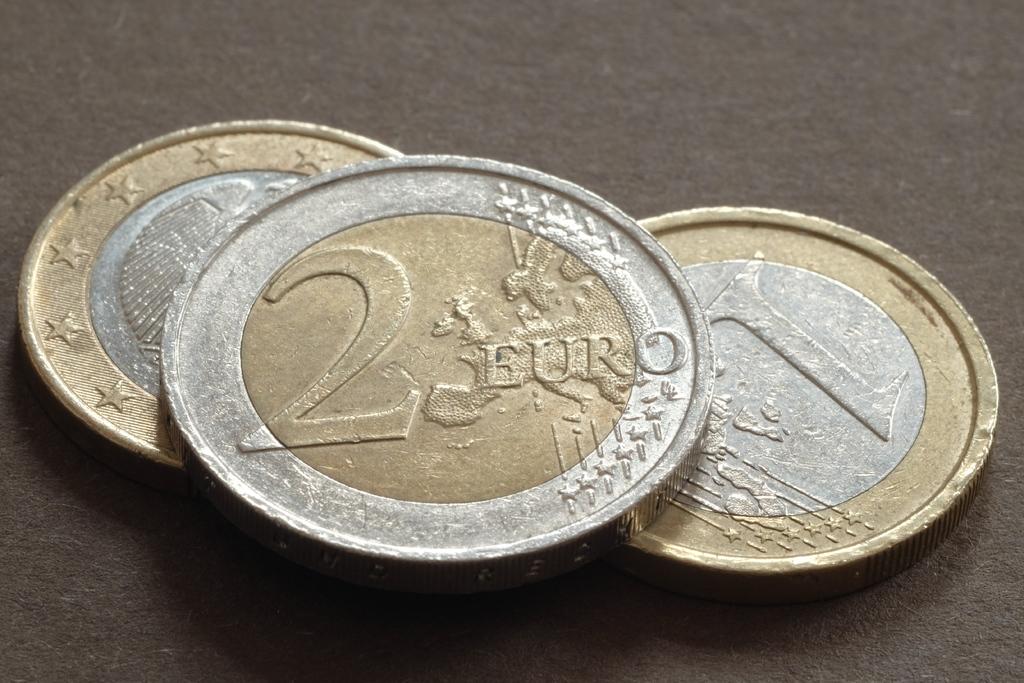How much money is that?
Your answer should be very brief. 2 euro. What is the 4 letter word on the coin?
Your response must be concise. Euro. 